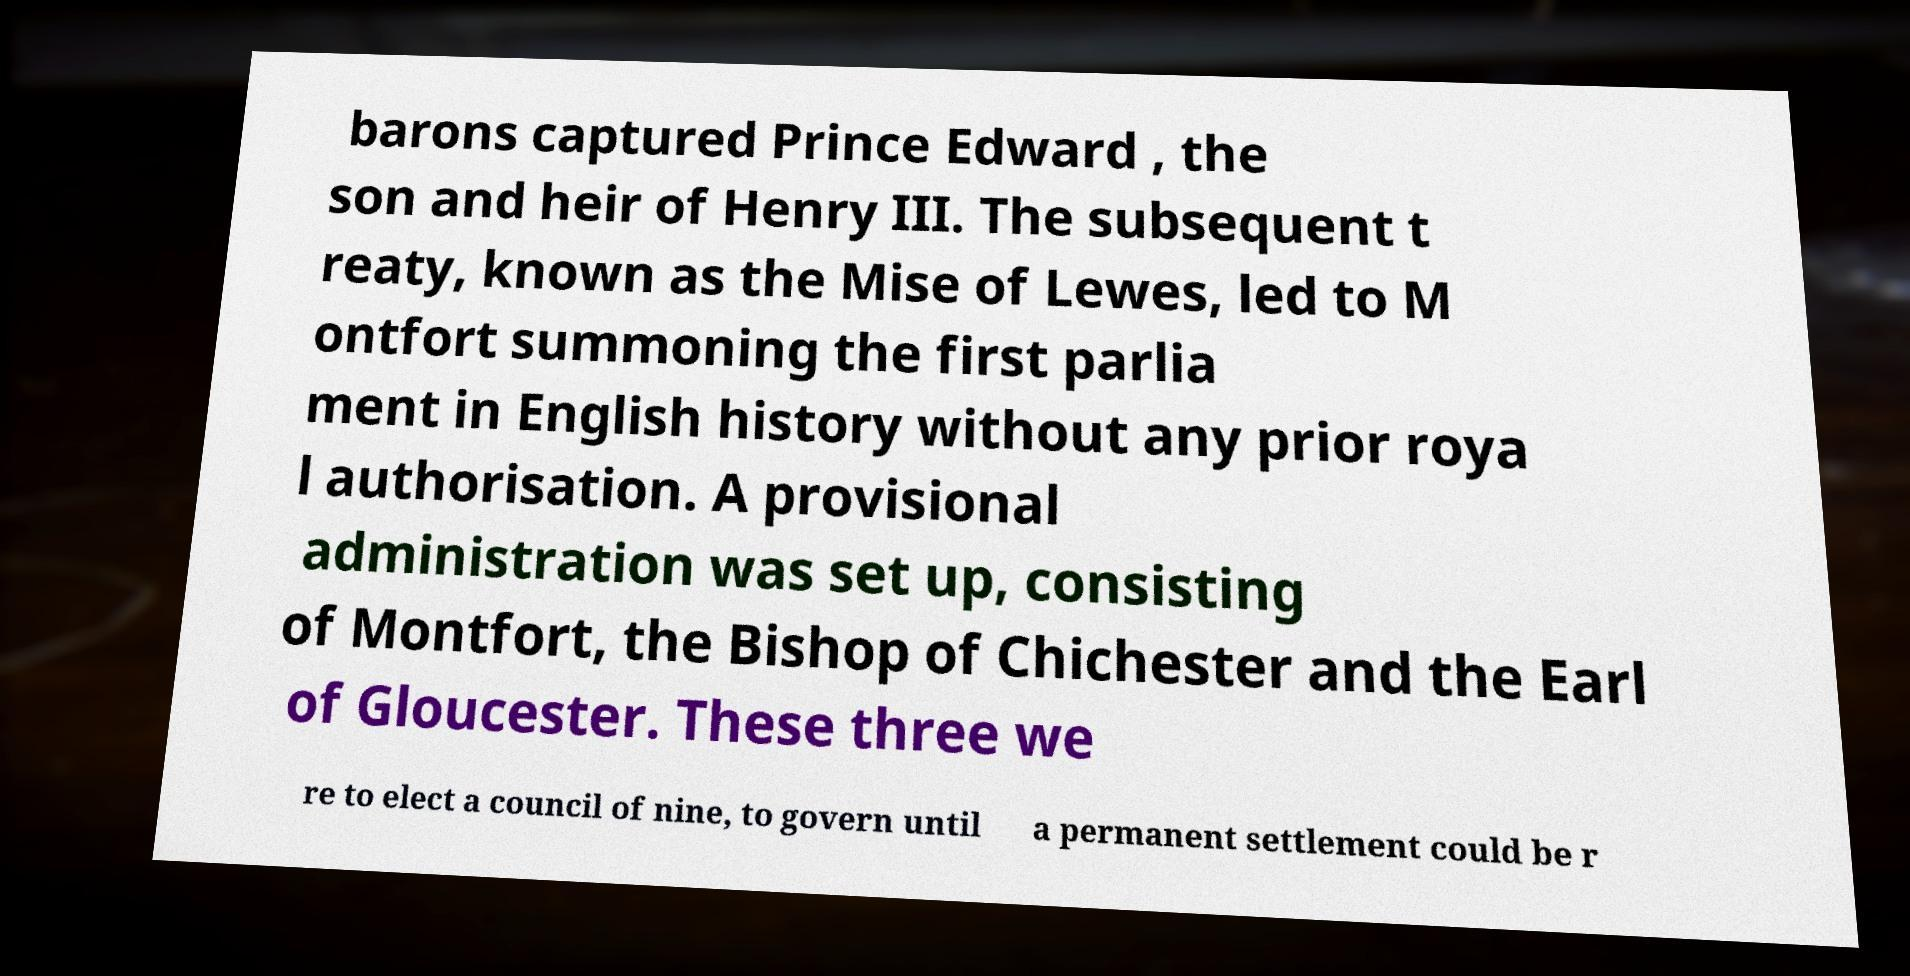Can you read and provide the text displayed in the image?This photo seems to have some interesting text. Can you extract and type it out for me? barons captured Prince Edward , the son and heir of Henry III. The subsequent t reaty, known as the Mise of Lewes, led to M ontfort summoning the first parlia ment in English history without any prior roya l authorisation. A provisional administration was set up, consisting of Montfort, the Bishop of Chichester and the Earl of Gloucester. These three we re to elect a council of nine, to govern until a permanent settlement could be r 